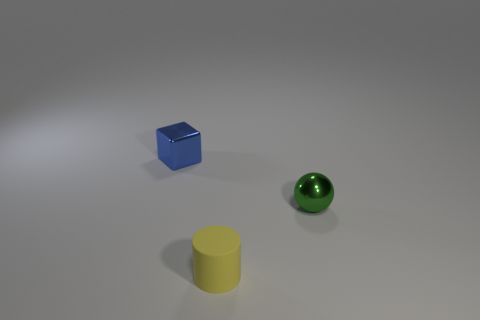Do the object behind the ball and the tiny green object have the same size?
Your answer should be compact. Yes. Is there any other thing that has the same shape as the small yellow object?
Your answer should be compact. No. What shape is the metallic object that is right of the yellow object?
Ensure brevity in your answer.  Sphere. What number of tiny blue metallic things are the same shape as the green shiny thing?
Offer a very short reply. 0. Do the small metal thing to the right of the blue object and the tiny metal object to the left of the matte object have the same color?
Offer a very short reply. No. How many things are green things or red metal blocks?
Provide a short and direct response. 1. What number of balls have the same material as the green object?
Provide a succinct answer. 0. Are there fewer tiny blue metal cubes than cyan cylinders?
Offer a terse response. No. Are the thing that is behind the tiny green metallic sphere and the green object made of the same material?
Keep it short and to the point. Yes. What number of cylinders are metal objects or green metal objects?
Your answer should be compact. 0. 